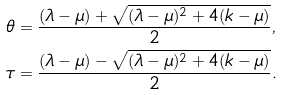Convert formula to latex. <formula><loc_0><loc_0><loc_500><loc_500>\theta & = \frac { ( \lambda - \mu ) + \sqrt { ( \lambda - \mu ) ^ { 2 } + 4 ( k - \mu ) } } { 2 } , \\ \tau & = \frac { ( \lambda - \mu ) - \sqrt { ( \lambda - \mu ) ^ { 2 } + 4 ( k - \mu ) } } { 2 } .</formula> 